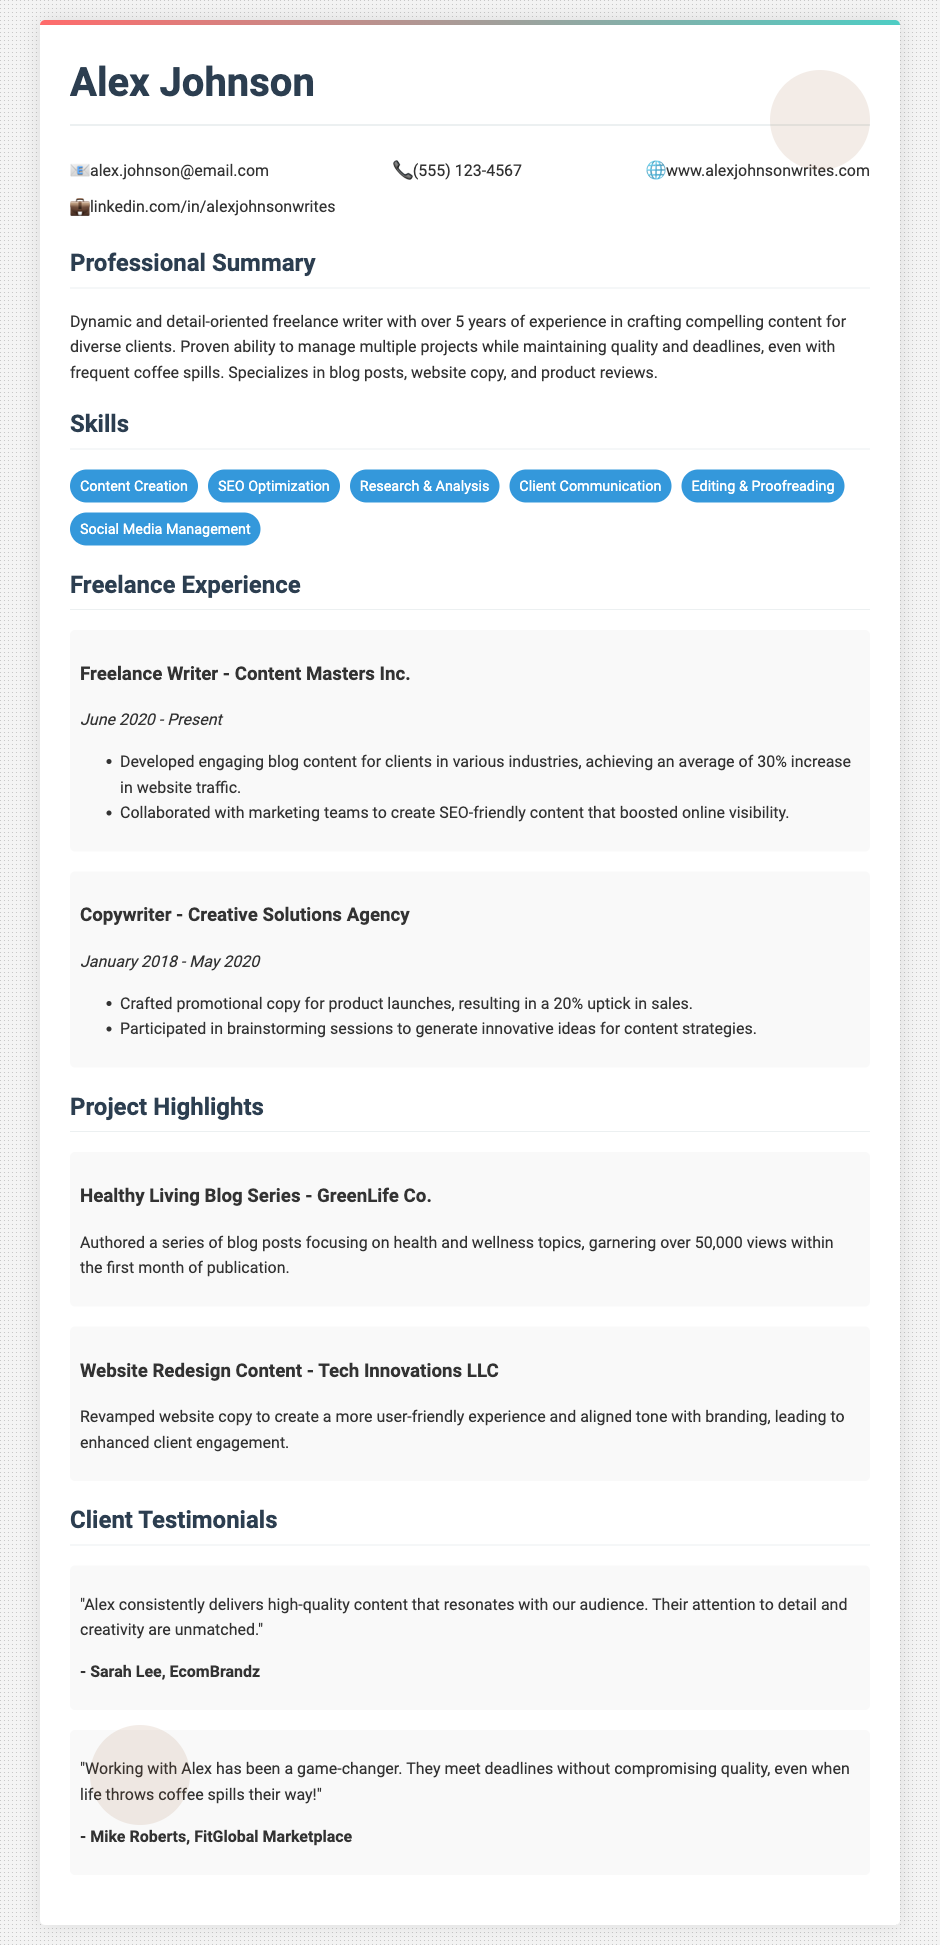What is the name of the freelancer? The document lists the freelancer's name at the top as Alex Johnson.
Answer: Alex Johnson How many years of experience does Alex have? The professional summary states that Alex has over 5 years of experience.
Answer: 5 years When did Alex start working for Creative Solutions Agency? The document specifies the start date as January 2018 for the position at Creative Solutions Agency.
Answer: January 2018 What significant increase did the blog content for Content Masters Inc. achieve? The document mentions an average of 30% increase in website traffic resulting from the blog content developed.
Answer: 30% Which project garnered over 50,000 views? The project highlight mentions a series of blog posts for GreenLife Co. earned over 50,000 views within the first month.
Answer: GreenLife Co Who provided a testimonial about Alex's attention to detail? The testimonial from Sarah Lee, EcomBrandz attributes high-quality content and attention to detail to Alex.
Answer: Sarah Lee What skill involves enhancing online visibility? The skills section includes SEO Optimization as the skill that helps in enhancing online visibility.
Answer: SEO Optimization Which company is associated with a website redesign project? The document highlights Tech Innovations LLC in relation to the website redesign project for which Alex revamped the copy.
Answer: Tech Innovations LLC What is Alex's email address? The contact info section provides Alex's email as alex.johnson@email.com.
Answer: alex.johnson@email.com 